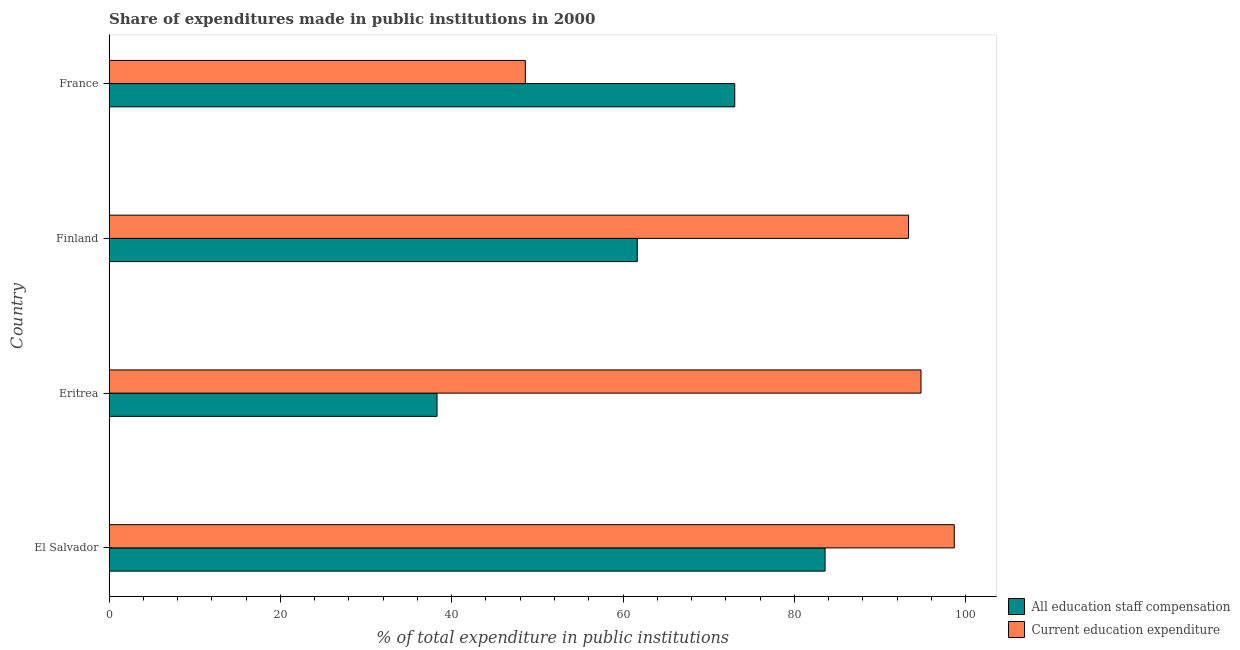What is the label of the 4th group of bars from the top?
Offer a terse response. El Salvador. In how many cases, is the number of bars for a given country not equal to the number of legend labels?
Give a very brief answer. 0. What is the expenditure in staff compensation in France?
Give a very brief answer. 73.04. Across all countries, what is the maximum expenditure in education?
Keep it short and to the point. 98.66. Across all countries, what is the minimum expenditure in staff compensation?
Ensure brevity in your answer.  38.29. In which country was the expenditure in staff compensation maximum?
Offer a very short reply. El Salvador. In which country was the expenditure in education minimum?
Offer a terse response. France. What is the total expenditure in education in the graph?
Ensure brevity in your answer.  335.37. What is the difference between the expenditure in staff compensation in Eritrea and that in Finland?
Offer a terse response. -23.37. What is the difference between the expenditure in education in Eritrea and the expenditure in staff compensation in Finland?
Offer a terse response. 33.12. What is the average expenditure in staff compensation per country?
Offer a very short reply. 64.14. What is the difference between the expenditure in staff compensation and expenditure in education in Eritrea?
Give a very brief answer. -56.49. What is the ratio of the expenditure in education in El Salvador to that in France?
Your response must be concise. 2.03. Is the expenditure in staff compensation in Eritrea less than that in Finland?
Provide a succinct answer. Yes. Is the difference between the expenditure in staff compensation in Finland and France greater than the difference between the expenditure in education in Finland and France?
Your answer should be very brief. No. What is the difference between the highest and the second highest expenditure in education?
Make the answer very short. 3.88. What is the difference between the highest and the lowest expenditure in staff compensation?
Make the answer very short. 45.3. What does the 2nd bar from the top in El Salvador represents?
Offer a very short reply. All education staff compensation. What does the 1st bar from the bottom in El Salvador represents?
Make the answer very short. All education staff compensation. Are all the bars in the graph horizontal?
Offer a very short reply. Yes. How many countries are there in the graph?
Your answer should be compact. 4. What is the difference between two consecutive major ticks on the X-axis?
Ensure brevity in your answer.  20. How many legend labels are there?
Your response must be concise. 2. How are the legend labels stacked?
Provide a short and direct response. Vertical. What is the title of the graph?
Your response must be concise. Share of expenditures made in public institutions in 2000. Does "Female" appear as one of the legend labels in the graph?
Give a very brief answer. No. What is the label or title of the X-axis?
Ensure brevity in your answer.  % of total expenditure in public institutions. What is the % of total expenditure in public institutions in All education staff compensation in El Salvador?
Provide a short and direct response. 83.58. What is the % of total expenditure in public institutions in Current education expenditure in El Salvador?
Give a very brief answer. 98.66. What is the % of total expenditure in public institutions of All education staff compensation in Eritrea?
Your answer should be compact. 38.29. What is the % of total expenditure in public institutions in Current education expenditure in Eritrea?
Your answer should be compact. 94.78. What is the % of total expenditure in public institutions in All education staff compensation in Finland?
Keep it short and to the point. 61.66. What is the % of total expenditure in public institutions of Current education expenditure in Finland?
Ensure brevity in your answer.  93.33. What is the % of total expenditure in public institutions of All education staff compensation in France?
Provide a short and direct response. 73.04. What is the % of total expenditure in public institutions of Current education expenditure in France?
Offer a very short reply. 48.59. Across all countries, what is the maximum % of total expenditure in public institutions in All education staff compensation?
Your answer should be compact. 83.58. Across all countries, what is the maximum % of total expenditure in public institutions of Current education expenditure?
Your answer should be very brief. 98.66. Across all countries, what is the minimum % of total expenditure in public institutions of All education staff compensation?
Provide a succinct answer. 38.29. Across all countries, what is the minimum % of total expenditure in public institutions in Current education expenditure?
Keep it short and to the point. 48.59. What is the total % of total expenditure in public institutions of All education staff compensation in the graph?
Ensure brevity in your answer.  256.57. What is the total % of total expenditure in public institutions in Current education expenditure in the graph?
Your response must be concise. 335.37. What is the difference between the % of total expenditure in public institutions in All education staff compensation in El Salvador and that in Eritrea?
Provide a succinct answer. 45.3. What is the difference between the % of total expenditure in public institutions of Current education expenditure in El Salvador and that in Eritrea?
Make the answer very short. 3.88. What is the difference between the % of total expenditure in public institutions of All education staff compensation in El Salvador and that in Finland?
Make the answer very short. 21.92. What is the difference between the % of total expenditure in public institutions in Current education expenditure in El Salvador and that in Finland?
Provide a short and direct response. 5.33. What is the difference between the % of total expenditure in public institutions of All education staff compensation in El Salvador and that in France?
Provide a short and direct response. 10.54. What is the difference between the % of total expenditure in public institutions of Current education expenditure in El Salvador and that in France?
Offer a terse response. 50.07. What is the difference between the % of total expenditure in public institutions in All education staff compensation in Eritrea and that in Finland?
Ensure brevity in your answer.  -23.37. What is the difference between the % of total expenditure in public institutions of Current education expenditure in Eritrea and that in Finland?
Make the answer very short. 1.45. What is the difference between the % of total expenditure in public institutions of All education staff compensation in Eritrea and that in France?
Make the answer very short. -34.75. What is the difference between the % of total expenditure in public institutions of Current education expenditure in Eritrea and that in France?
Make the answer very short. 46.19. What is the difference between the % of total expenditure in public institutions in All education staff compensation in Finland and that in France?
Offer a very short reply. -11.38. What is the difference between the % of total expenditure in public institutions in Current education expenditure in Finland and that in France?
Your answer should be very brief. 44.74. What is the difference between the % of total expenditure in public institutions in All education staff compensation in El Salvador and the % of total expenditure in public institutions in Current education expenditure in Eritrea?
Provide a short and direct response. -11.2. What is the difference between the % of total expenditure in public institutions of All education staff compensation in El Salvador and the % of total expenditure in public institutions of Current education expenditure in Finland?
Your answer should be compact. -9.75. What is the difference between the % of total expenditure in public institutions of All education staff compensation in El Salvador and the % of total expenditure in public institutions of Current education expenditure in France?
Offer a very short reply. 34.99. What is the difference between the % of total expenditure in public institutions in All education staff compensation in Eritrea and the % of total expenditure in public institutions in Current education expenditure in Finland?
Offer a very short reply. -55.04. What is the difference between the % of total expenditure in public institutions in All education staff compensation in Eritrea and the % of total expenditure in public institutions in Current education expenditure in France?
Provide a succinct answer. -10.31. What is the difference between the % of total expenditure in public institutions in All education staff compensation in Finland and the % of total expenditure in public institutions in Current education expenditure in France?
Give a very brief answer. 13.06. What is the average % of total expenditure in public institutions in All education staff compensation per country?
Provide a short and direct response. 64.14. What is the average % of total expenditure in public institutions of Current education expenditure per country?
Make the answer very short. 83.84. What is the difference between the % of total expenditure in public institutions in All education staff compensation and % of total expenditure in public institutions in Current education expenditure in El Salvador?
Your response must be concise. -15.08. What is the difference between the % of total expenditure in public institutions in All education staff compensation and % of total expenditure in public institutions in Current education expenditure in Eritrea?
Offer a very short reply. -56.49. What is the difference between the % of total expenditure in public institutions in All education staff compensation and % of total expenditure in public institutions in Current education expenditure in Finland?
Make the answer very short. -31.67. What is the difference between the % of total expenditure in public institutions of All education staff compensation and % of total expenditure in public institutions of Current education expenditure in France?
Keep it short and to the point. 24.45. What is the ratio of the % of total expenditure in public institutions in All education staff compensation in El Salvador to that in Eritrea?
Make the answer very short. 2.18. What is the ratio of the % of total expenditure in public institutions of Current education expenditure in El Salvador to that in Eritrea?
Provide a succinct answer. 1.04. What is the ratio of the % of total expenditure in public institutions of All education staff compensation in El Salvador to that in Finland?
Make the answer very short. 1.36. What is the ratio of the % of total expenditure in public institutions of Current education expenditure in El Salvador to that in Finland?
Provide a succinct answer. 1.06. What is the ratio of the % of total expenditure in public institutions in All education staff compensation in El Salvador to that in France?
Provide a succinct answer. 1.14. What is the ratio of the % of total expenditure in public institutions of Current education expenditure in El Salvador to that in France?
Your answer should be very brief. 2.03. What is the ratio of the % of total expenditure in public institutions in All education staff compensation in Eritrea to that in Finland?
Offer a terse response. 0.62. What is the ratio of the % of total expenditure in public institutions of Current education expenditure in Eritrea to that in Finland?
Offer a very short reply. 1.02. What is the ratio of the % of total expenditure in public institutions of All education staff compensation in Eritrea to that in France?
Offer a terse response. 0.52. What is the ratio of the % of total expenditure in public institutions of Current education expenditure in Eritrea to that in France?
Offer a terse response. 1.95. What is the ratio of the % of total expenditure in public institutions of All education staff compensation in Finland to that in France?
Provide a short and direct response. 0.84. What is the ratio of the % of total expenditure in public institutions in Current education expenditure in Finland to that in France?
Your answer should be compact. 1.92. What is the difference between the highest and the second highest % of total expenditure in public institutions in All education staff compensation?
Provide a succinct answer. 10.54. What is the difference between the highest and the second highest % of total expenditure in public institutions of Current education expenditure?
Offer a very short reply. 3.88. What is the difference between the highest and the lowest % of total expenditure in public institutions of All education staff compensation?
Your answer should be compact. 45.3. What is the difference between the highest and the lowest % of total expenditure in public institutions of Current education expenditure?
Keep it short and to the point. 50.07. 